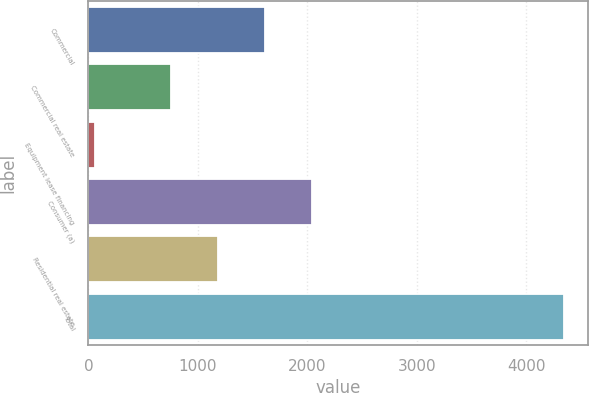<chart> <loc_0><loc_0><loc_500><loc_500><bar_chart><fcel>Commercial<fcel>Commercial real estate<fcel>Equipment lease financing<fcel>Consumer (a)<fcel>Residential real estate<fcel>Total<nl><fcel>1610<fcel>753<fcel>62<fcel>2038.5<fcel>1181.5<fcel>4347<nl></chart> 